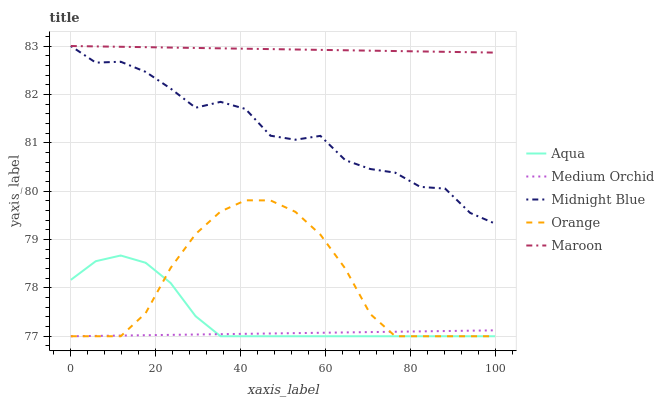Does Medium Orchid have the minimum area under the curve?
Answer yes or no. Yes. Does Maroon have the maximum area under the curve?
Answer yes or no. Yes. Does Aqua have the minimum area under the curve?
Answer yes or no. No. Does Aqua have the maximum area under the curve?
Answer yes or no. No. Is Medium Orchid the smoothest?
Answer yes or no. Yes. Is Midnight Blue the roughest?
Answer yes or no. Yes. Is Aqua the smoothest?
Answer yes or no. No. Is Aqua the roughest?
Answer yes or no. No. Does Midnight Blue have the lowest value?
Answer yes or no. No. Does Maroon have the highest value?
Answer yes or no. Yes. Does Aqua have the highest value?
Answer yes or no. No. Is Medium Orchid less than Maroon?
Answer yes or no. Yes. Is Maroon greater than Aqua?
Answer yes or no. Yes. Does Midnight Blue intersect Maroon?
Answer yes or no. Yes. Is Midnight Blue less than Maroon?
Answer yes or no. No. Is Midnight Blue greater than Maroon?
Answer yes or no. No. Does Medium Orchid intersect Maroon?
Answer yes or no. No. 